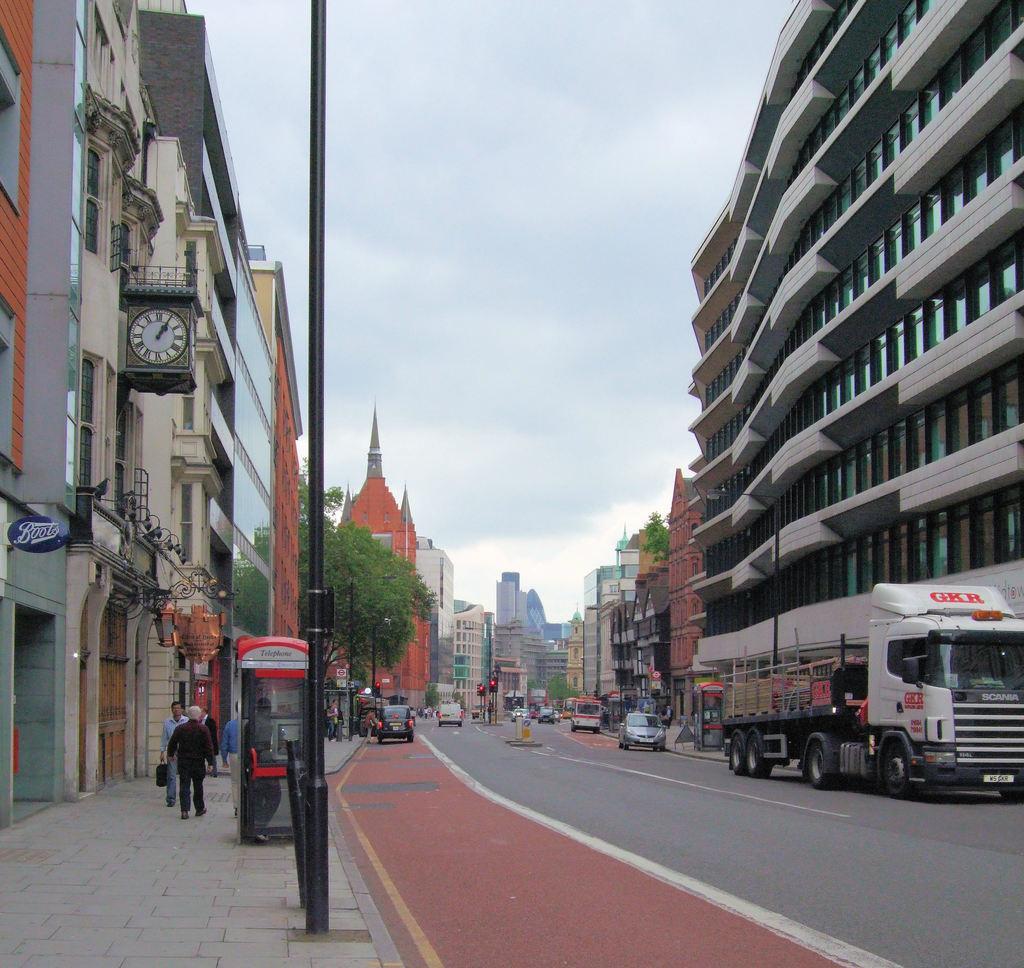In one or two sentences, can you explain what this image depicts? In the picture we can see a road on the either sides of the road we can see buildings, and on the path we can see some tree, poles and some people walking on it and on the road we can see some vehicles like cars and truck and in the background also we can see some buildings and sky with clouds. 